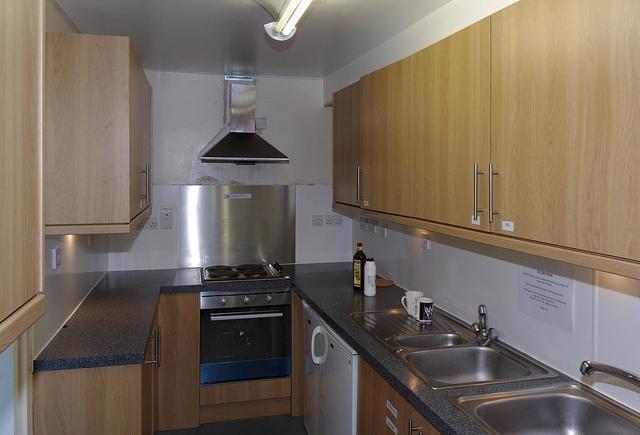How many sinks are there?
Give a very brief answer. 2. 